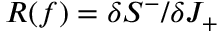Convert formula to latex. <formula><loc_0><loc_0><loc_500><loc_500>R ( f ) = \delta S ^ { - } / \delta J _ { + }</formula> 